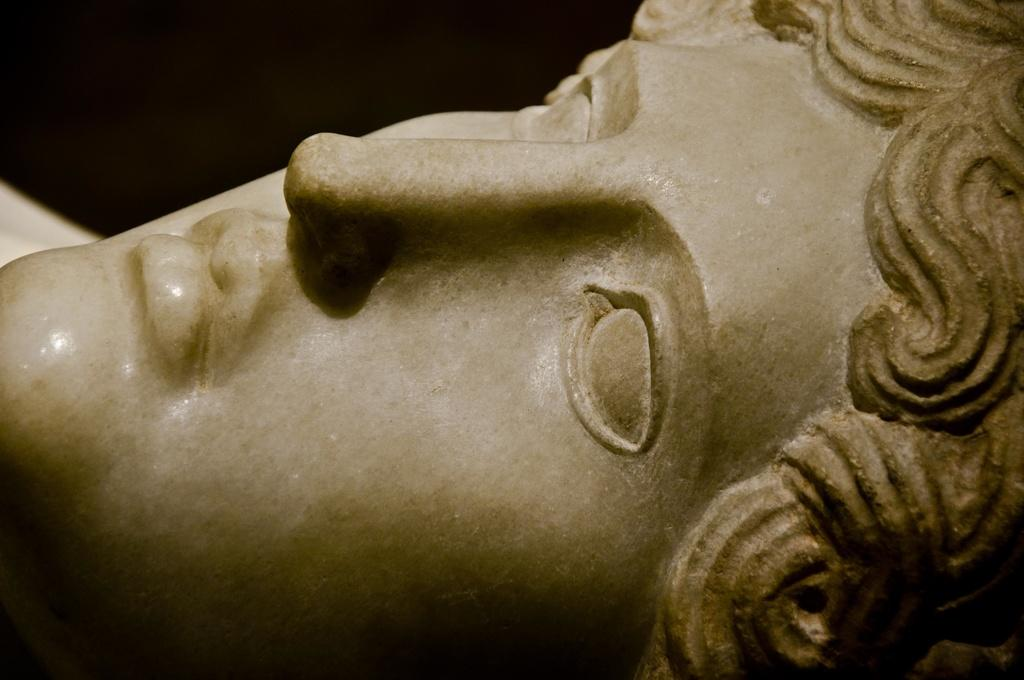What is the main subject of the image? There is a statue in the image. What type of stew is being served in the image? There is no stew present in the image; it features a statue. How many sheep can be seen grazing near the statue in the image? There are no sheep present in the image; it features a statue. 